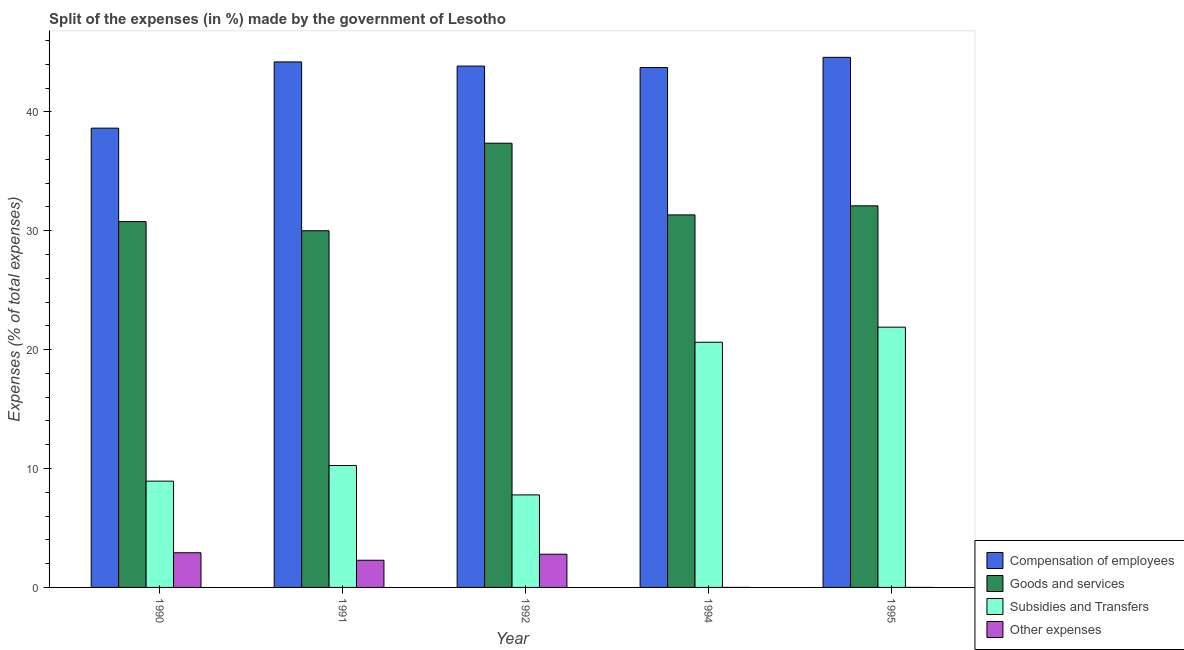How many different coloured bars are there?
Provide a succinct answer. 4. How many groups of bars are there?
Your answer should be very brief. 5. How many bars are there on the 1st tick from the left?
Your answer should be very brief. 4. What is the percentage of amount spent on goods and services in 1994?
Your answer should be compact. 31.33. Across all years, what is the maximum percentage of amount spent on compensation of employees?
Offer a terse response. 44.58. Across all years, what is the minimum percentage of amount spent on compensation of employees?
Keep it short and to the point. 38.63. In which year was the percentage of amount spent on subsidies maximum?
Ensure brevity in your answer.  1995. What is the total percentage of amount spent on goods and services in the graph?
Provide a short and direct response. 161.56. What is the difference between the percentage of amount spent on goods and services in 1991 and that in 1995?
Your response must be concise. -2.1. What is the difference between the percentage of amount spent on compensation of employees in 1994 and the percentage of amount spent on other expenses in 1990?
Give a very brief answer. 5.1. What is the average percentage of amount spent on compensation of employees per year?
Your answer should be compact. 43. In how many years, is the percentage of amount spent on subsidies greater than 20 %?
Keep it short and to the point. 2. What is the ratio of the percentage of amount spent on goods and services in 1990 to that in 1994?
Your answer should be compact. 0.98. Is the percentage of amount spent on subsidies in 1990 less than that in 1992?
Keep it short and to the point. No. What is the difference between the highest and the second highest percentage of amount spent on compensation of employees?
Make the answer very short. 0.39. What is the difference between the highest and the lowest percentage of amount spent on subsidies?
Keep it short and to the point. 14.11. What does the 3rd bar from the left in 1994 represents?
Offer a very short reply. Subsidies and Transfers. What does the 1st bar from the right in 1992 represents?
Your answer should be compact. Other expenses. Are the values on the major ticks of Y-axis written in scientific E-notation?
Your answer should be compact. No. Does the graph contain any zero values?
Make the answer very short. No. Where does the legend appear in the graph?
Provide a succinct answer. Bottom right. What is the title of the graph?
Offer a very short reply. Split of the expenses (in %) made by the government of Lesotho. What is the label or title of the X-axis?
Offer a very short reply. Year. What is the label or title of the Y-axis?
Give a very brief answer. Expenses (% of total expenses). What is the Expenses (% of total expenses) of Compensation of employees in 1990?
Provide a short and direct response. 38.63. What is the Expenses (% of total expenses) of Goods and services in 1990?
Your answer should be compact. 30.77. What is the Expenses (% of total expenses) of Subsidies and Transfers in 1990?
Offer a very short reply. 8.94. What is the Expenses (% of total expenses) of Other expenses in 1990?
Make the answer very short. 2.92. What is the Expenses (% of total expenses) in Compensation of employees in 1991?
Offer a very short reply. 44.2. What is the Expenses (% of total expenses) in Goods and services in 1991?
Your answer should be very brief. 30. What is the Expenses (% of total expenses) in Subsidies and Transfers in 1991?
Your response must be concise. 10.25. What is the Expenses (% of total expenses) in Other expenses in 1991?
Offer a terse response. 2.28. What is the Expenses (% of total expenses) of Compensation of employees in 1992?
Keep it short and to the point. 43.85. What is the Expenses (% of total expenses) of Goods and services in 1992?
Your answer should be very brief. 37.36. What is the Expenses (% of total expenses) in Subsidies and Transfers in 1992?
Provide a succinct answer. 7.78. What is the Expenses (% of total expenses) of Other expenses in 1992?
Ensure brevity in your answer.  2.79. What is the Expenses (% of total expenses) of Compensation of employees in 1994?
Offer a very short reply. 43.73. What is the Expenses (% of total expenses) of Goods and services in 1994?
Make the answer very short. 31.33. What is the Expenses (% of total expenses) in Subsidies and Transfers in 1994?
Offer a terse response. 20.62. What is the Expenses (% of total expenses) of Other expenses in 1994?
Give a very brief answer. 2.999997087200831e-5. What is the Expenses (% of total expenses) in Compensation of employees in 1995?
Make the answer very short. 44.58. What is the Expenses (% of total expenses) in Goods and services in 1995?
Make the answer very short. 32.1. What is the Expenses (% of total expenses) of Subsidies and Transfers in 1995?
Your response must be concise. 21.89. What is the Expenses (% of total expenses) of Other expenses in 1995?
Keep it short and to the point. 0. Across all years, what is the maximum Expenses (% of total expenses) of Compensation of employees?
Offer a very short reply. 44.58. Across all years, what is the maximum Expenses (% of total expenses) of Goods and services?
Provide a succinct answer. 37.36. Across all years, what is the maximum Expenses (% of total expenses) of Subsidies and Transfers?
Keep it short and to the point. 21.89. Across all years, what is the maximum Expenses (% of total expenses) of Other expenses?
Offer a very short reply. 2.92. Across all years, what is the minimum Expenses (% of total expenses) in Compensation of employees?
Your answer should be compact. 38.63. Across all years, what is the minimum Expenses (% of total expenses) of Goods and services?
Ensure brevity in your answer.  30. Across all years, what is the minimum Expenses (% of total expenses) of Subsidies and Transfers?
Make the answer very short. 7.78. Across all years, what is the minimum Expenses (% of total expenses) in Other expenses?
Keep it short and to the point. 2.999997087200831e-5. What is the total Expenses (% of total expenses) in Compensation of employees in the graph?
Provide a short and direct response. 214.99. What is the total Expenses (% of total expenses) of Goods and services in the graph?
Ensure brevity in your answer.  161.56. What is the total Expenses (% of total expenses) of Subsidies and Transfers in the graph?
Offer a terse response. 69.48. What is the total Expenses (% of total expenses) of Other expenses in the graph?
Your answer should be very brief. 7.99. What is the difference between the Expenses (% of total expenses) in Compensation of employees in 1990 and that in 1991?
Provide a short and direct response. -5.57. What is the difference between the Expenses (% of total expenses) in Goods and services in 1990 and that in 1991?
Your answer should be compact. 0.77. What is the difference between the Expenses (% of total expenses) of Subsidies and Transfers in 1990 and that in 1991?
Offer a very short reply. -1.31. What is the difference between the Expenses (% of total expenses) of Other expenses in 1990 and that in 1991?
Keep it short and to the point. 0.63. What is the difference between the Expenses (% of total expenses) of Compensation of employees in 1990 and that in 1992?
Your answer should be very brief. -5.22. What is the difference between the Expenses (% of total expenses) in Goods and services in 1990 and that in 1992?
Your answer should be very brief. -6.59. What is the difference between the Expenses (% of total expenses) in Subsidies and Transfers in 1990 and that in 1992?
Keep it short and to the point. 1.16. What is the difference between the Expenses (% of total expenses) of Other expenses in 1990 and that in 1992?
Your response must be concise. 0.13. What is the difference between the Expenses (% of total expenses) in Compensation of employees in 1990 and that in 1994?
Give a very brief answer. -5.1. What is the difference between the Expenses (% of total expenses) in Goods and services in 1990 and that in 1994?
Make the answer very short. -0.56. What is the difference between the Expenses (% of total expenses) of Subsidies and Transfers in 1990 and that in 1994?
Give a very brief answer. -11.68. What is the difference between the Expenses (% of total expenses) in Other expenses in 1990 and that in 1994?
Ensure brevity in your answer.  2.92. What is the difference between the Expenses (% of total expenses) in Compensation of employees in 1990 and that in 1995?
Provide a succinct answer. -5.96. What is the difference between the Expenses (% of total expenses) of Goods and services in 1990 and that in 1995?
Make the answer very short. -1.33. What is the difference between the Expenses (% of total expenses) in Subsidies and Transfers in 1990 and that in 1995?
Make the answer very short. -12.95. What is the difference between the Expenses (% of total expenses) in Other expenses in 1990 and that in 1995?
Your answer should be very brief. 2.92. What is the difference between the Expenses (% of total expenses) in Compensation of employees in 1991 and that in 1992?
Offer a terse response. 0.35. What is the difference between the Expenses (% of total expenses) of Goods and services in 1991 and that in 1992?
Your response must be concise. -7.36. What is the difference between the Expenses (% of total expenses) of Subsidies and Transfers in 1991 and that in 1992?
Offer a terse response. 2.47. What is the difference between the Expenses (% of total expenses) of Other expenses in 1991 and that in 1992?
Your answer should be very brief. -0.51. What is the difference between the Expenses (% of total expenses) in Compensation of employees in 1991 and that in 1994?
Ensure brevity in your answer.  0.47. What is the difference between the Expenses (% of total expenses) of Goods and services in 1991 and that in 1994?
Provide a short and direct response. -1.33. What is the difference between the Expenses (% of total expenses) of Subsidies and Transfers in 1991 and that in 1994?
Your response must be concise. -10.37. What is the difference between the Expenses (% of total expenses) of Other expenses in 1991 and that in 1994?
Ensure brevity in your answer.  2.28. What is the difference between the Expenses (% of total expenses) of Compensation of employees in 1991 and that in 1995?
Your answer should be compact. -0.39. What is the difference between the Expenses (% of total expenses) of Goods and services in 1991 and that in 1995?
Provide a succinct answer. -2.1. What is the difference between the Expenses (% of total expenses) in Subsidies and Transfers in 1991 and that in 1995?
Your answer should be compact. -11.64. What is the difference between the Expenses (% of total expenses) in Other expenses in 1991 and that in 1995?
Offer a terse response. 2.28. What is the difference between the Expenses (% of total expenses) in Compensation of employees in 1992 and that in 1994?
Offer a very short reply. 0.12. What is the difference between the Expenses (% of total expenses) in Goods and services in 1992 and that in 1994?
Provide a short and direct response. 6.03. What is the difference between the Expenses (% of total expenses) of Subsidies and Transfers in 1992 and that in 1994?
Offer a very short reply. -12.84. What is the difference between the Expenses (% of total expenses) of Other expenses in 1992 and that in 1994?
Offer a very short reply. 2.79. What is the difference between the Expenses (% of total expenses) of Compensation of employees in 1992 and that in 1995?
Provide a short and direct response. -0.74. What is the difference between the Expenses (% of total expenses) of Goods and services in 1992 and that in 1995?
Offer a very short reply. 5.27. What is the difference between the Expenses (% of total expenses) in Subsidies and Transfers in 1992 and that in 1995?
Provide a short and direct response. -14.11. What is the difference between the Expenses (% of total expenses) of Other expenses in 1992 and that in 1995?
Ensure brevity in your answer.  2.79. What is the difference between the Expenses (% of total expenses) in Compensation of employees in 1994 and that in 1995?
Your response must be concise. -0.86. What is the difference between the Expenses (% of total expenses) in Goods and services in 1994 and that in 1995?
Your response must be concise. -0.76. What is the difference between the Expenses (% of total expenses) of Subsidies and Transfers in 1994 and that in 1995?
Your response must be concise. -1.27. What is the difference between the Expenses (% of total expenses) of Other expenses in 1994 and that in 1995?
Your answer should be very brief. -0. What is the difference between the Expenses (% of total expenses) in Compensation of employees in 1990 and the Expenses (% of total expenses) in Goods and services in 1991?
Your answer should be compact. 8.63. What is the difference between the Expenses (% of total expenses) in Compensation of employees in 1990 and the Expenses (% of total expenses) in Subsidies and Transfers in 1991?
Give a very brief answer. 28.38. What is the difference between the Expenses (% of total expenses) of Compensation of employees in 1990 and the Expenses (% of total expenses) of Other expenses in 1991?
Your answer should be very brief. 36.34. What is the difference between the Expenses (% of total expenses) in Goods and services in 1990 and the Expenses (% of total expenses) in Subsidies and Transfers in 1991?
Provide a succinct answer. 20.52. What is the difference between the Expenses (% of total expenses) in Goods and services in 1990 and the Expenses (% of total expenses) in Other expenses in 1991?
Offer a very short reply. 28.48. What is the difference between the Expenses (% of total expenses) in Subsidies and Transfers in 1990 and the Expenses (% of total expenses) in Other expenses in 1991?
Provide a succinct answer. 6.65. What is the difference between the Expenses (% of total expenses) of Compensation of employees in 1990 and the Expenses (% of total expenses) of Goods and services in 1992?
Give a very brief answer. 1.27. What is the difference between the Expenses (% of total expenses) in Compensation of employees in 1990 and the Expenses (% of total expenses) in Subsidies and Transfers in 1992?
Give a very brief answer. 30.85. What is the difference between the Expenses (% of total expenses) of Compensation of employees in 1990 and the Expenses (% of total expenses) of Other expenses in 1992?
Provide a succinct answer. 35.84. What is the difference between the Expenses (% of total expenses) in Goods and services in 1990 and the Expenses (% of total expenses) in Subsidies and Transfers in 1992?
Give a very brief answer. 22.99. What is the difference between the Expenses (% of total expenses) of Goods and services in 1990 and the Expenses (% of total expenses) of Other expenses in 1992?
Offer a very short reply. 27.98. What is the difference between the Expenses (% of total expenses) of Subsidies and Transfers in 1990 and the Expenses (% of total expenses) of Other expenses in 1992?
Your answer should be compact. 6.15. What is the difference between the Expenses (% of total expenses) in Compensation of employees in 1990 and the Expenses (% of total expenses) in Goods and services in 1994?
Give a very brief answer. 7.3. What is the difference between the Expenses (% of total expenses) of Compensation of employees in 1990 and the Expenses (% of total expenses) of Subsidies and Transfers in 1994?
Your answer should be compact. 18.01. What is the difference between the Expenses (% of total expenses) of Compensation of employees in 1990 and the Expenses (% of total expenses) of Other expenses in 1994?
Offer a very short reply. 38.63. What is the difference between the Expenses (% of total expenses) of Goods and services in 1990 and the Expenses (% of total expenses) of Subsidies and Transfers in 1994?
Give a very brief answer. 10.15. What is the difference between the Expenses (% of total expenses) of Goods and services in 1990 and the Expenses (% of total expenses) of Other expenses in 1994?
Make the answer very short. 30.77. What is the difference between the Expenses (% of total expenses) of Subsidies and Transfers in 1990 and the Expenses (% of total expenses) of Other expenses in 1994?
Provide a succinct answer. 8.94. What is the difference between the Expenses (% of total expenses) of Compensation of employees in 1990 and the Expenses (% of total expenses) of Goods and services in 1995?
Your response must be concise. 6.53. What is the difference between the Expenses (% of total expenses) in Compensation of employees in 1990 and the Expenses (% of total expenses) in Subsidies and Transfers in 1995?
Ensure brevity in your answer.  16.74. What is the difference between the Expenses (% of total expenses) in Compensation of employees in 1990 and the Expenses (% of total expenses) in Other expenses in 1995?
Provide a short and direct response. 38.63. What is the difference between the Expenses (% of total expenses) in Goods and services in 1990 and the Expenses (% of total expenses) in Subsidies and Transfers in 1995?
Your response must be concise. 8.88. What is the difference between the Expenses (% of total expenses) of Goods and services in 1990 and the Expenses (% of total expenses) of Other expenses in 1995?
Offer a terse response. 30.77. What is the difference between the Expenses (% of total expenses) in Subsidies and Transfers in 1990 and the Expenses (% of total expenses) in Other expenses in 1995?
Ensure brevity in your answer.  8.94. What is the difference between the Expenses (% of total expenses) of Compensation of employees in 1991 and the Expenses (% of total expenses) of Goods and services in 1992?
Offer a terse response. 6.84. What is the difference between the Expenses (% of total expenses) in Compensation of employees in 1991 and the Expenses (% of total expenses) in Subsidies and Transfers in 1992?
Keep it short and to the point. 36.42. What is the difference between the Expenses (% of total expenses) of Compensation of employees in 1991 and the Expenses (% of total expenses) of Other expenses in 1992?
Your answer should be compact. 41.41. What is the difference between the Expenses (% of total expenses) in Goods and services in 1991 and the Expenses (% of total expenses) in Subsidies and Transfers in 1992?
Make the answer very short. 22.22. What is the difference between the Expenses (% of total expenses) of Goods and services in 1991 and the Expenses (% of total expenses) of Other expenses in 1992?
Keep it short and to the point. 27.21. What is the difference between the Expenses (% of total expenses) of Subsidies and Transfers in 1991 and the Expenses (% of total expenses) of Other expenses in 1992?
Provide a short and direct response. 7.46. What is the difference between the Expenses (% of total expenses) in Compensation of employees in 1991 and the Expenses (% of total expenses) in Goods and services in 1994?
Your response must be concise. 12.87. What is the difference between the Expenses (% of total expenses) in Compensation of employees in 1991 and the Expenses (% of total expenses) in Subsidies and Transfers in 1994?
Your answer should be compact. 23.58. What is the difference between the Expenses (% of total expenses) of Compensation of employees in 1991 and the Expenses (% of total expenses) of Other expenses in 1994?
Give a very brief answer. 44.2. What is the difference between the Expenses (% of total expenses) in Goods and services in 1991 and the Expenses (% of total expenses) in Subsidies and Transfers in 1994?
Keep it short and to the point. 9.38. What is the difference between the Expenses (% of total expenses) of Goods and services in 1991 and the Expenses (% of total expenses) of Other expenses in 1994?
Give a very brief answer. 30. What is the difference between the Expenses (% of total expenses) in Subsidies and Transfers in 1991 and the Expenses (% of total expenses) in Other expenses in 1994?
Make the answer very short. 10.25. What is the difference between the Expenses (% of total expenses) in Compensation of employees in 1991 and the Expenses (% of total expenses) in Goods and services in 1995?
Offer a terse response. 12.1. What is the difference between the Expenses (% of total expenses) in Compensation of employees in 1991 and the Expenses (% of total expenses) in Subsidies and Transfers in 1995?
Your answer should be very brief. 22.31. What is the difference between the Expenses (% of total expenses) in Compensation of employees in 1991 and the Expenses (% of total expenses) in Other expenses in 1995?
Offer a very short reply. 44.2. What is the difference between the Expenses (% of total expenses) in Goods and services in 1991 and the Expenses (% of total expenses) in Subsidies and Transfers in 1995?
Make the answer very short. 8.11. What is the difference between the Expenses (% of total expenses) in Goods and services in 1991 and the Expenses (% of total expenses) in Other expenses in 1995?
Offer a terse response. 30. What is the difference between the Expenses (% of total expenses) of Subsidies and Transfers in 1991 and the Expenses (% of total expenses) of Other expenses in 1995?
Make the answer very short. 10.25. What is the difference between the Expenses (% of total expenses) of Compensation of employees in 1992 and the Expenses (% of total expenses) of Goods and services in 1994?
Make the answer very short. 12.52. What is the difference between the Expenses (% of total expenses) of Compensation of employees in 1992 and the Expenses (% of total expenses) of Subsidies and Transfers in 1994?
Provide a short and direct response. 23.23. What is the difference between the Expenses (% of total expenses) of Compensation of employees in 1992 and the Expenses (% of total expenses) of Other expenses in 1994?
Give a very brief answer. 43.85. What is the difference between the Expenses (% of total expenses) in Goods and services in 1992 and the Expenses (% of total expenses) in Subsidies and Transfers in 1994?
Make the answer very short. 16.74. What is the difference between the Expenses (% of total expenses) of Goods and services in 1992 and the Expenses (% of total expenses) of Other expenses in 1994?
Offer a terse response. 37.36. What is the difference between the Expenses (% of total expenses) of Subsidies and Transfers in 1992 and the Expenses (% of total expenses) of Other expenses in 1994?
Offer a terse response. 7.78. What is the difference between the Expenses (% of total expenses) of Compensation of employees in 1992 and the Expenses (% of total expenses) of Goods and services in 1995?
Make the answer very short. 11.75. What is the difference between the Expenses (% of total expenses) of Compensation of employees in 1992 and the Expenses (% of total expenses) of Subsidies and Transfers in 1995?
Offer a very short reply. 21.96. What is the difference between the Expenses (% of total expenses) of Compensation of employees in 1992 and the Expenses (% of total expenses) of Other expenses in 1995?
Provide a succinct answer. 43.85. What is the difference between the Expenses (% of total expenses) of Goods and services in 1992 and the Expenses (% of total expenses) of Subsidies and Transfers in 1995?
Your answer should be compact. 15.47. What is the difference between the Expenses (% of total expenses) in Goods and services in 1992 and the Expenses (% of total expenses) in Other expenses in 1995?
Ensure brevity in your answer.  37.36. What is the difference between the Expenses (% of total expenses) of Subsidies and Transfers in 1992 and the Expenses (% of total expenses) of Other expenses in 1995?
Your response must be concise. 7.78. What is the difference between the Expenses (% of total expenses) of Compensation of employees in 1994 and the Expenses (% of total expenses) of Goods and services in 1995?
Your answer should be compact. 11.63. What is the difference between the Expenses (% of total expenses) of Compensation of employees in 1994 and the Expenses (% of total expenses) of Subsidies and Transfers in 1995?
Keep it short and to the point. 21.84. What is the difference between the Expenses (% of total expenses) of Compensation of employees in 1994 and the Expenses (% of total expenses) of Other expenses in 1995?
Give a very brief answer. 43.73. What is the difference between the Expenses (% of total expenses) in Goods and services in 1994 and the Expenses (% of total expenses) in Subsidies and Transfers in 1995?
Your answer should be very brief. 9.44. What is the difference between the Expenses (% of total expenses) of Goods and services in 1994 and the Expenses (% of total expenses) of Other expenses in 1995?
Make the answer very short. 31.33. What is the difference between the Expenses (% of total expenses) of Subsidies and Transfers in 1994 and the Expenses (% of total expenses) of Other expenses in 1995?
Your answer should be compact. 20.62. What is the average Expenses (% of total expenses) of Compensation of employees per year?
Give a very brief answer. 43. What is the average Expenses (% of total expenses) of Goods and services per year?
Make the answer very short. 32.31. What is the average Expenses (% of total expenses) in Subsidies and Transfers per year?
Provide a short and direct response. 13.9. What is the average Expenses (% of total expenses) of Other expenses per year?
Give a very brief answer. 1.6. In the year 1990, what is the difference between the Expenses (% of total expenses) in Compensation of employees and Expenses (% of total expenses) in Goods and services?
Provide a succinct answer. 7.86. In the year 1990, what is the difference between the Expenses (% of total expenses) in Compensation of employees and Expenses (% of total expenses) in Subsidies and Transfers?
Offer a terse response. 29.69. In the year 1990, what is the difference between the Expenses (% of total expenses) in Compensation of employees and Expenses (% of total expenses) in Other expenses?
Provide a short and direct response. 35.71. In the year 1990, what is the difference between the Expenses (% of total expenses) of Goods and services and Expenses (% of total expenses) of Subsidies and Transfers?
Give a very brief answer. 21.83. In the year 1990, what is the difference between the Expenses (% of total expenses) of Goods and services and Expenses (% of total expenses) of Other expenses?
Provide a succinct answer. 27.85. In the year 1990, what is the difference between the Expenses (% of total expenses) of Subsidies and Transfers and Expenses (% of total expenses) of Other expenses?
Make the answer very short. 6.02. In the year 1991, what is the difference between the Expenses (% of total expenses) in Compensation of employees and Expenses (% of total expenses) in Goods and services?
Ensure brevity in your answer.  14.2. In the year 1991, what is the difference between the Expenses (% of total expenses) in Compensation of employees and Expenses (% of total expenses) in Subsidies and Transfers?
Offer a very short reply. 33.95. In the year 1991, what is the difference between the Expenses (% of total expenses) of Compensation of employees and Expenses (% of total expenses) of Other expenses?
Provide a short and direct response. 41.91. In the year 1991, what is the difference between the Expenses (% of total expenses) of Goods and services and Expenses (% of total expenses) of Subsidies and Transfers?
Provide a succinct answer. 19.74. In the year 1991, what is the difference between the Expenses (% of total expenses) in Goods and services and Expenses (% of total expenses) in Other expenses?
Ensure brevity in your answer.  27.71. In the year 1991, what is the difference between the Expenses (% of total expenses) of Subsidies and Transfers and Expenses (% of total expenses) of Other expenses?
Offer a terse response. 7.97. In the year 1992, what is the difference between the Expenses (% of total expenses) in Compensation of employees and Expenses (% of total expenses) in Goods and services?
Give a very brief answer. 6.49. In the year 1992, what is the difference between the Expenses (% of total expenses) in Compensation of employees and Expenses (% of total expenses) in Subsidies and Transfers?
Make the answer very short. 36.07. In the year 1992, what is the difference between the Expenses (% of total expenses) of Compensation of employees and Expenses (% of total expenses) of Other expenses?
Keep it short and to the point. 41.06. In the year 1992, what is the difference between the Expenses (% of total expenses) in Goods and services and Expenses (% of total expenses) in Subsidies and Transfers?
Provide a succinct answer. 29.58. In the year 1992, what is the difference between the Expenses (% of total expenses) in Goods and services and Expenses (% of total expenses) in Other expenses?
Make the answer very short. 34.57. In the year 1992, what is the difference between the Expenses (% of total expenses) of Subsidies and Transfers and Expenses (% of total expenses) of Other expenses?
Ensure brevity in your answer.  4.99. In the year 1994, what is the difference between the Expenses (% of total expenses) in Compensation of employees and Expenses (% of total expenses) in Goods and services?
Offer a terse response. 12.39. In the year 1994, what is the difference between the Expenses (% of total expenses) of Compensation of employees and Expenses (% of total expenses) of Subsidies and Transfers?
Provide a short and direct response. 23.11. In the year 1994, what is the difference between the Expenses (% of total expenses) in Compensation of employees and Expenses (% of total expenses) in Other expenses?
Your response must be concise. 43.73. In the year 1994, what is the difference between the Expenses (% of total expenses) in Goods and services and Expenses (% of total expenses) in Subsidies and Transfers?
Give a very brief answer. 10.71. In the year 1994, what is the difference between the Expenses (% of total expenses) in Goods and services and Expenses (% of total expenses) in Other expenses?
Keep it short and to the point. 31.33. In the year 1994, what is the difference between the Expenses (% of total expenses) of Subsidies and Transfers and Expenses (% of total expenses) of Other expenses?
Keep it short and to the point. 20.62. In the year 1995, what is the difference between the Expenses (% of total expenses) in Compensation of employees and Expenses (% of total expenses) in Goods and services?
Provide a succinct answer. 12.49. In the year 1995, what is the difference between the Expenses (% of total expenses) of Compensation of employees and Expenses (% of total expenses) of Subsidies and Transfers?
Your response must be concise. 22.7. In the year 1995, what is the difference between the Expenses (% of total expenses) of Compensation of employees and Expenses (% of total expenses) of Other expenses?
Offer a very short reply. 44.58. In the year 1995, what is the difference between the Expenses (% of total expenses) of Goods and services and Expenses (% of total expenses) of Subsidies and Transfers?
Make the answer very short. 10.21. In the year 1995, what is the difference between the Expenses (% of total expenses) of Goods and services and Expenses (% of total expenses) of Other expenses?
Offer a terse response. 32.1. In the year 1995, what is the difference between the Expenses (% of total expenses) of Subsidies and Transfers and Expenses (% of total expenses) of Other expenses?
Provide a short and direct response. 21.89. What is the ratio of the Expenses (% of total expenses) of Compensation of employees in 1990 to that in 1991?
Your answer should be compact. 0.87. What is the ratio of the Expenses (% of total expenses) of Goods and services in 1990 to that in 1991?
Your answer should be very brief. 1.03. What is the ratio of the Expenses (% of total expenses) of Subsidies and Transfers in 1990 to that in 1991?
Your answer should be compact. 0.87. What is the ratio of the Expenses (% of total expenses) in Other expenses in 1990 to that in 1991?
Provide a short and direct response. 1.28. What is the ratio of the Expenses (% of total expenses) of Compensation of employees in 1990 to that in 1992?
Give a very brief answer. 0.88. What is the ratio of the Expenses (% of total expenses) in Goods and services in 1990 to that in 1992?
Your answer should be compact. 0.82. What is the ratio of the Expenses (% of total expenses) of Subsidies and Transfers in 1990 to that in 1992?
Ensure brevity in your answer.  1.15. What is the ratio of the Expenses (% of total expenses) in Other expenses in 1990 to that in 1992?
Your answer should be very brief. 1.04. What is the ratio of the Expenses (% of total expenses) in Compensation of employees in 1990 to that in 1994?
Make the answer very short. 0.88. What is the ratio of the Expenses (% of total expenses) of Goods and services in 1990 to that in 1994?
Ensure brevity in your answer.  0.98. What is the ratio of the Expenses (% of total expenses) in Subsidies and Transfers in 1990 to that in 1994?
Make the answer very short. 0.43. What is the ratio of the Expenses (% of total expenses) of Other expenses in 1990 to that in 1994?
Keep it short and to the point. 9.72e+04. What is the ratio of the Expenses (% of total expenses) of Compensation of employees in 1990 to that in 1995?
Your answer should be very brief. 0.87. What is the ratio of the Expenses (% of total expenses) of Goods and services in 1990 to that in 1995?
Your answer should be compact. 0.96. What is the ratio of the Expenses (% of total expenses) of Subsidies and Transfers in 1990 to that in 1995?
Offer a very short reply. 0.41. What is the ratio of the Expenses (% of total expenses) of Other expenses in 1990 to that in 1995?
Provide a short and direct response. 2.91e+04. What is the ratio of the Expenses (% of total expenses) in Goods and services in 1991 to that in 1992?
Make the answer very short. 0.8. What is the ratio of the Expenses (% of total expenses) of Subsidies and Transfers in 1991 to that in 1992?
Give a very brief answer. 1.32. What is the ratio of the Expenses (% of total expenses) of Other expenses in 1991 to that in 1992?
Offer a terse response. 0.82. What is the ratio of the Expenses (% of total expenses) of Compensation of employees in 1991 to that in 1994?
Ensure brevity in your answer.  1.01. What is the ratio of the Expenses (% of total expenses) of Goods and services in 1991 to that in 1994?
Provide a succinct answer. 0.96. What is the ratio of the Expenses (% of total expenses) of Subsidies and Transfers in 1991 to that in 1994?
Provide a succinct answer. 0.5. What is the ratio of the Expenses (% of total expenses) of Other expenses in 1991 to that in 1994?
Keep it short and to the point. 7.62e+04. What is the ratio of the Expenses (% of total expenses) of Goods and services in 1991 to that in 1995?
Offer a very short reply. 0.93. What is the ratio of the Expenses (% of total expenses) of Subsidies and Transfers in 1991 to that in 1995?
Provide a succinct answer. 0.47. What is the ratio of the Expenses (% of total expenses) of Other expenses in 1991 to that in 1995?
Give a very brief answer. 2.28e+04. What is the ratio of the Expenses (% of total expenses) of Compensation of employees in 1992 to that in 1994?
Keep it short and to the point. 1. What is the ratio of the Expenses (% of total expenses) in Goods and services in 1992 to that in 1994?
Keep it short and to the point. 1.19. What is the ratio of the Expenses (% of total expenses) in Subsidies and Transfers in 1992 to that in 1994?
Provide a succinct answer. 0.38. What is the ratio of the Expenses (% of total expenses) of Other expenses in 1992 to that in 1994?
Your answer should be compact. 9.30e+04. What is the ratio of the Expenses (% of total expenses) in Compensation of employees in 1992 to that in 1995?
Your answer should be very brief. 0.98. What is the ratio of the Expenses (% of total expenses) in Goods and services in 1992 to that in 1995?
Your answer should be compact. 1.16. What is the ratio of the Expenses (% of total expenses) in Subsidies and Transfers in 1992 to that in 1995?
Provide a short and direct response. 0.36. What is the ratio of the Expenses (% of total expenses) of Other expenses in 1992 to that in 1995?
Your answer should be compact. 2.78e+04. What is the ratio of the Expenses (% of total expenses) in Compensation of employees in 1994 to that in 1995?
Offer a very short reply. 0.98. What is the ratio of the Expenses (% of total expenses) in Goods and services in 1994 to that in 1995?
Make the answer very short. 0.98. What is the ratio of the Expenses (% of total expenses) of Subsidies and Transfers in 1994 to that in 1995?
Provide a short and direct response. 0.94. What is the ratio of the Expenses (% of total expenses) in Other expenses in 1994 to that in 1995?
Give a very brief answer. 0.3. What is the difference between the highest and the second highest Expenses (% of total expenses) in Compensation of employees?
Your response must be concise. 0.39. What is the difference between the highest and the second highest Expenses (% of total expenses) in Goods and services?
Ensure brevity in your answer.  5.27. What is the difference between the highest and the second highest Expenses (% of total expenses) in Subsidies and Transfers?
Your answer should be very brief. 1.27. What is the difference between the highest and the second highest Expenses (% of total expenses) in Other expenses?
Keep it short and to the point. 0.13. What is the difference between the highest and the lowest Expenses (% of total expenses) of Compensation of employees?
Make the answer very short. 5.96. What is the difference between the highest and the lowest Expenses (% of total expenses) of Goods and services?
Give a very brief answer. 7.36. What is the difference between the highest and the lowest Expenses (% of total expenses) in Subsidies and Transfers?
Ensure brevity in your answer.  14.11. What is the difference between the highest and the lowest Expenses (% of total expenses) of Other expenses?
Ensure brevity in your answer.  2.92. 